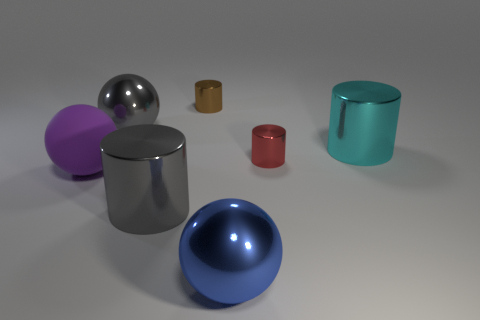Are there an equal number of gray cylinders in front of the blue shiny thing and gray shiny things?
Offer a terse response. No. There is a gray cylinder that is on the left side of the metal cylinder that is behind the cyan object behind the gray cylinder; what is its material?
Offer a terse response. Metal. How many objects are either big metal things that are in front of the gray metallic sphere or tiny gray balls?
Give a very brief answer. 3. What number of things are either red metallic things or gray metal cylinders on the right side of the big purple rubber object?
Your answer should be compact. 2. There is a big gray thing that is behind the big shiny cylinder that is in front of the large purple ball; what number of metal things are to the right of it?
Give a very brief answer. 5. What material is the cyan cylinder that is the same size as the gray shiny sphere?
Give a very brief answer. Metal. Is there a cyan metallic thing that has the same size as the cyan cylinder?
Provide a succinct answer. No. The large matte object is what color?
Give a very brief answer. Purple. There is a tiny metal thing behind the tiny cylinder that is right of the large blue object; what color is it?
Keep it short and to the point. Brown. What is the shape of the gray metal thing that is behind the cylinder in front of the purple ball that is on the left side of the gray metal cylinder?
Your response must be concise. Sphere. 